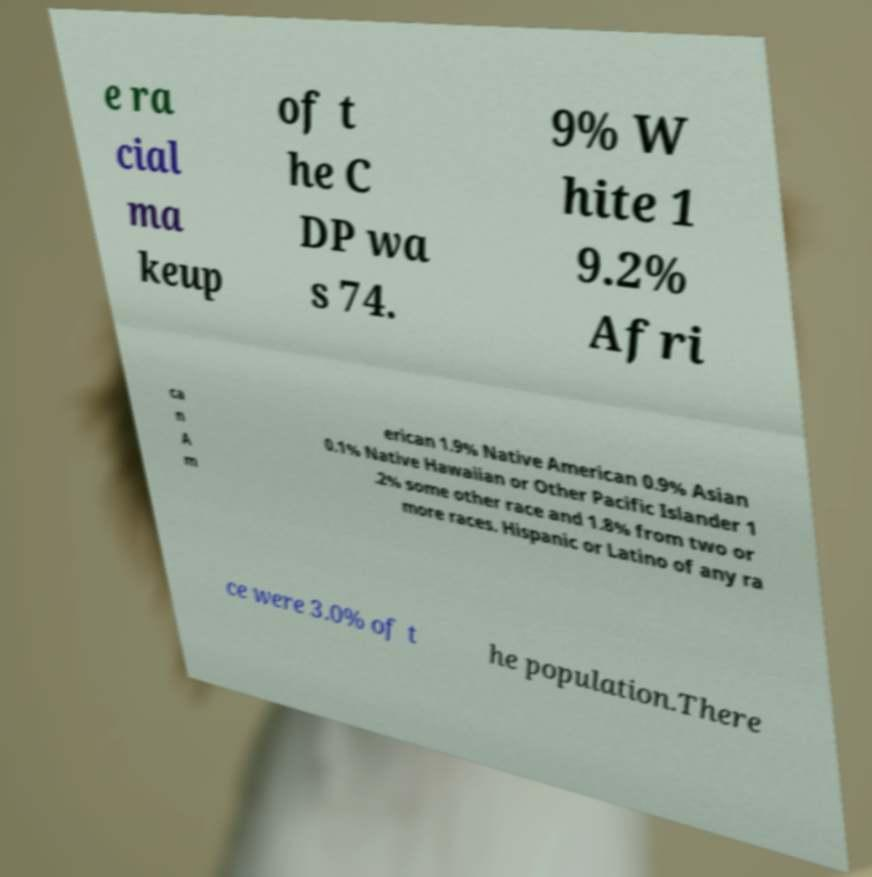For documentation purposes, I need the text within this image transcribed. Could you provide that? e ra cial ma keup of t he C DP wa s 74. 9% W hite 1 9.2% Afri ca n A m erican 1.9% Native American 0.9% Asian 0.1% Native Hawaiian or Other Pacific Islander 1 .2% some other race and 1.8% from two or more races. Hispanic or Latino of any ra ce were 3.0% of t he population.There 